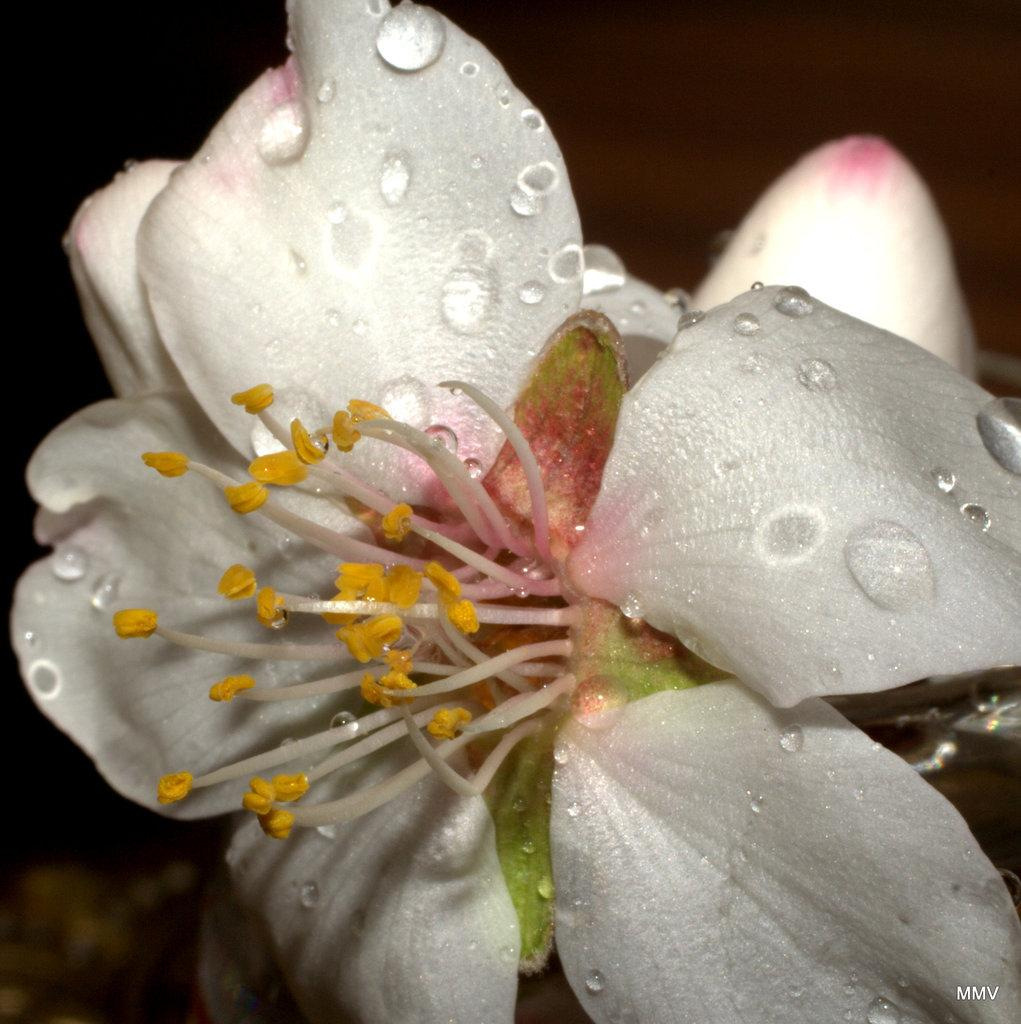What is the main subject of the image? There is a flower in the image. What can be observed about the background of the image? The background of the image is dark. Is there any additional information or marking on the image? Yes, there is a watermark on the image. What type of hat is the father wearing in the image? There is no father or hat present in the image; it features a flower and a dark background. Is there a volcano visible in the image? No, there is no volcano present in the image; it features a flower and a dark background. 